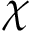Convert formula to latex. <formula><loc_0><loc_0><loc_500><loc_500>\chi</formula> 